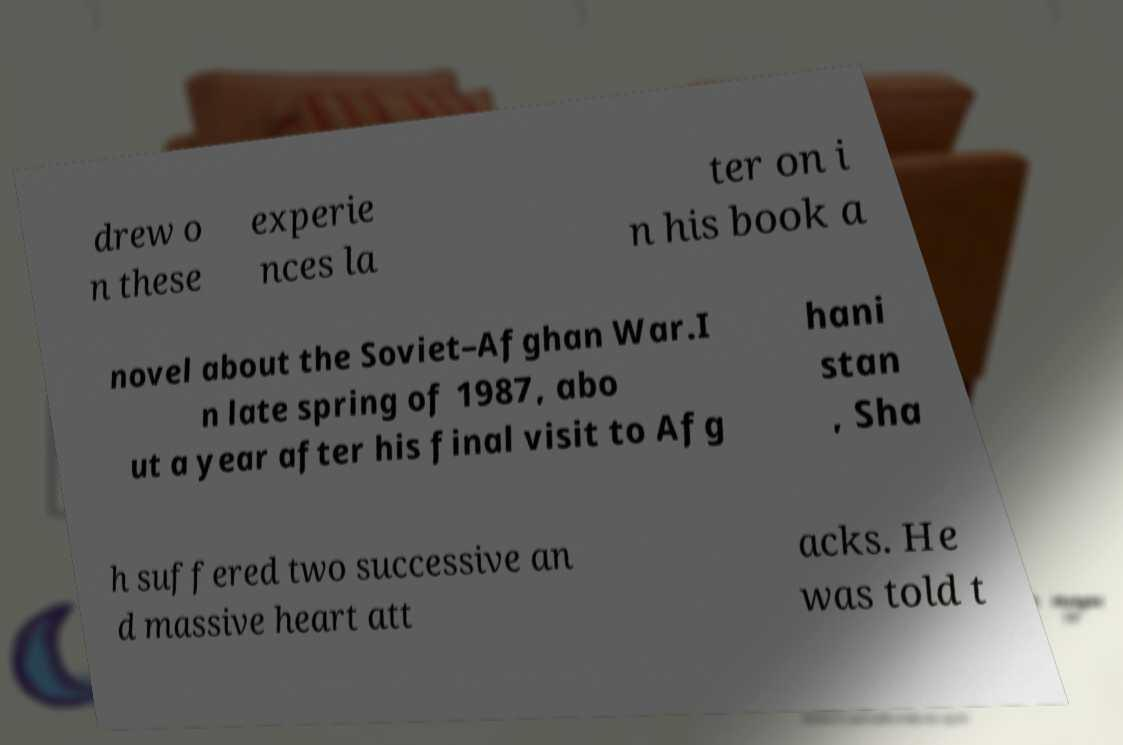Could you assist in decoding the text presented in this image and type it out clearly? drew o n these experie nces la ter on i n his book a novel about the Soviet–Afghan War.I n late spring of 1987, abo ut a year after his final visit to Afg hani stan , Sha h suffered two successive an d massive heart att acks. He was told t 